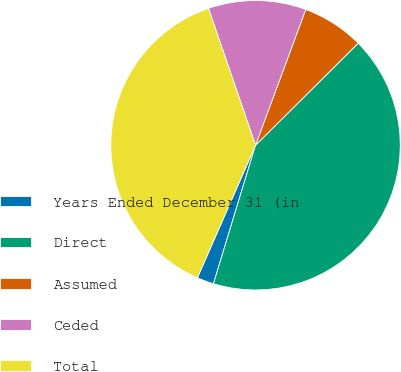Convert chart to OTSL. <chart><loc_0><loc_0><loc_500><loc_500><pie_chart><fcel>Years Ended December 31 (in<fcel>Direct<fcel>Assumed<fcel>Ceded<fcel>Total<nl><fcel>1.88%<fcel>42.15%<fcel>6.91%<fcel>10.91%<fcel>38.15%<nl></chart> 